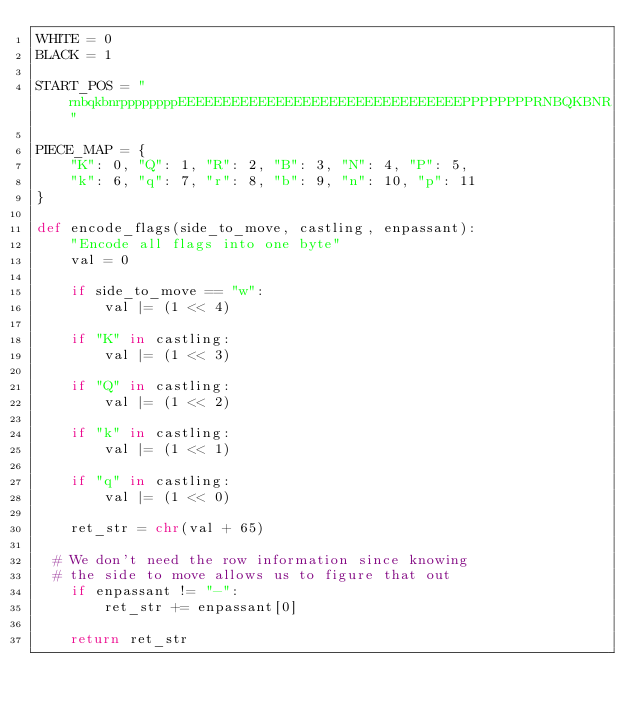Convert code to text. <code><loc_0><loc_0><loc_500><loc_500><_Python_>WHITE = 0
BLACK = 1

START_POS = "rnbqkbnrppppppppEEEEEEEEEEEEEEEEEEEEEEEEEEEEEEEEPPPPPPPPRNBQKBNR"

PIECE_MAP = {
    "K": 0, "Q": 1, "R": 2, "B": 3, "N": 4, "P": 5,
    "k": 6, "q": 7, "r": 8, "b": 9, "n": 10, "p": 11
}

def encode_flags(side_to_move, castling, enpassant):
    "Encode all flags into one byte"
    val = 0

    if side_to_move == "w":
        val |= (1 << 4)

    if "K" in castling:
        val |= (1 << 3)

    if "Q" in castling:
        val |= (1 << 2)

    if "k" in castling:
        val |= (1 << 1)

    if "q" in castling:
        val |= (1 << 0)

    ret_str = chr(val + 65)

	# We don't need the row information since knowing
	# the side to move allows us to figure that out
    if enpassant != "-":
        ret_str += enpassant[0]

    return ret_str
</code> 